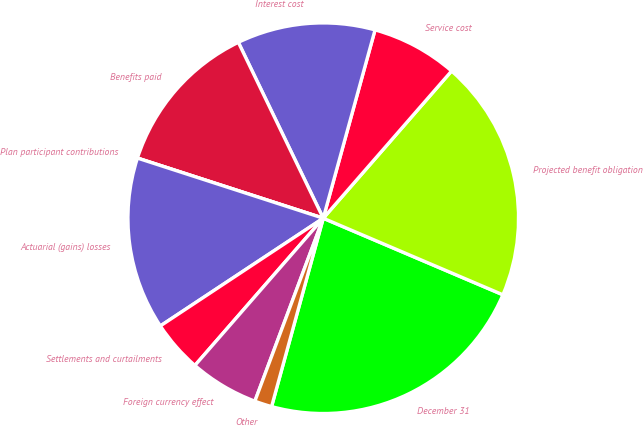<chart> <loc_0><loc_0><loc_500><loc_500><pie_chart><fcel>December 31<fcel>Projected benefit obligation<fcel>Service cost<fcel>Interest cost<fcel>Benefits paid<fcel>Plan participant contributions<fcel>Actuarial (gains) losses<fcel>Settlements and curtailments<fcel>Foreign currency effect<fcel>Other<nl><fcel>22.85%<fcel>20.0%<fcel>7.14%<fcel>11.43%<fcel>12.86%<fcel>0.0%<fcel>14.28%<fcel>4.29%<fcel>5.72%<fcel>1.43%<nl></chart> 